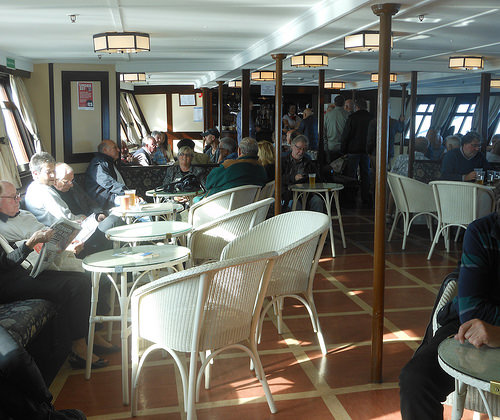<image>
Can you confirm if the chair is on the body? No. The chair is not positioned on the body. They may be near each other, but the chair is not supported by or resting on top of the body. 